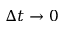<formula> <loc_0><loc_0><loc_500><loc_500>\Delta t \rightarrow 0</formula> 